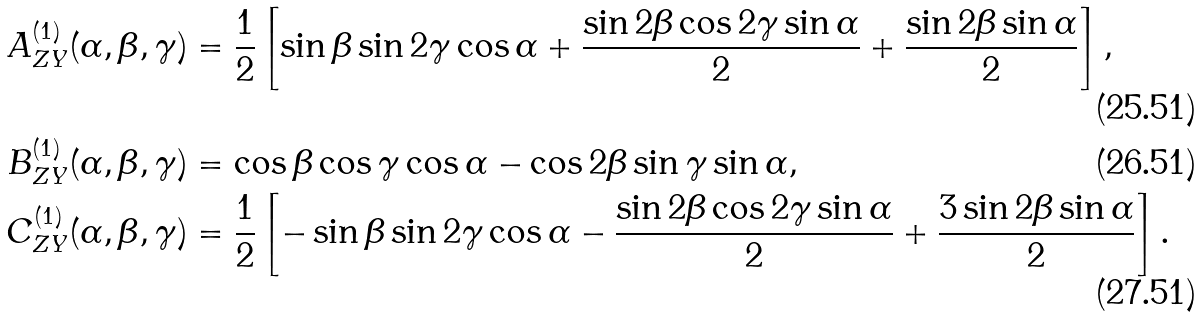<formula> <loc_0><loc_0><loc_500><loc_500>A _ { Z Y } ^ { ( 1 ) } ( \alpha , \beta , \gamma ) & = \frac { 1 } { 2 } \left [ \sin \beta \sin 2 \gamma \cos \alpha + \frac { \sin 2 \beta \cos 2 \gamma \sin \alpha } { 2 } + \frac { \sin 2 \beta \sin \alpha } { 2 } \right ] , \\ B _ { Z Y } ^ { ( 1 ) } ( \alpha , \beta , \gamma ) & = \cos \beta \cos \gamma \cos \alpha - \cos 2 \beta \sin \gamma \sin \alpha , \\ C _ { Z Y } ^ { ( 1 ) } ( \alpha , \beta , \gamma ) & = \frac { 1 } { 2 } \left [ - \sin \beta \sin 2 \gamma \cos \alpha - \frac { \sin 2 \beta \cos 2 \gamma \sin \alpha } { 2 } + \frac { 3 \sin 2 \beta \sin \alpha } { 2 } \right ] .</formula> 